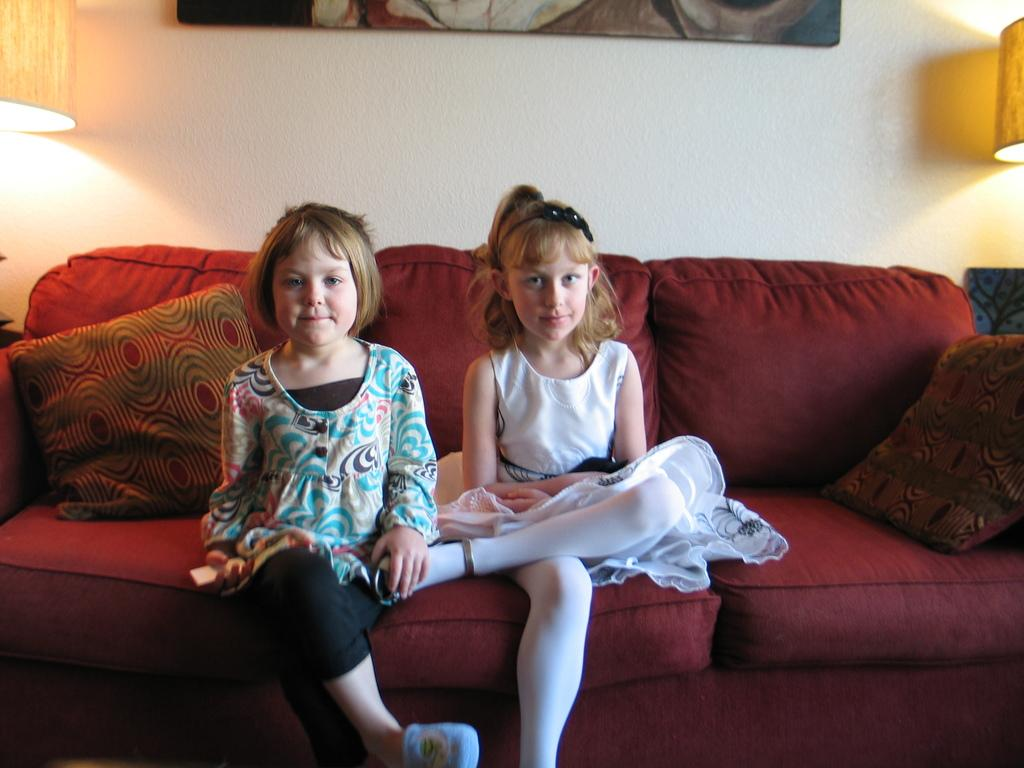How many girls are in the image? There are two girls in the image. What are the girls doing in the image? The girls are sitting on a couch and smiling. Can you describe the furniture in the image? There are two cushions on the couch. What can be seen in the background of the image? There is a white wall, a showpiece, and lamps in the background. How many legs does the plant have in the image? There is no plant present in the image, so it is not possible to determine the number of legs it might have. 